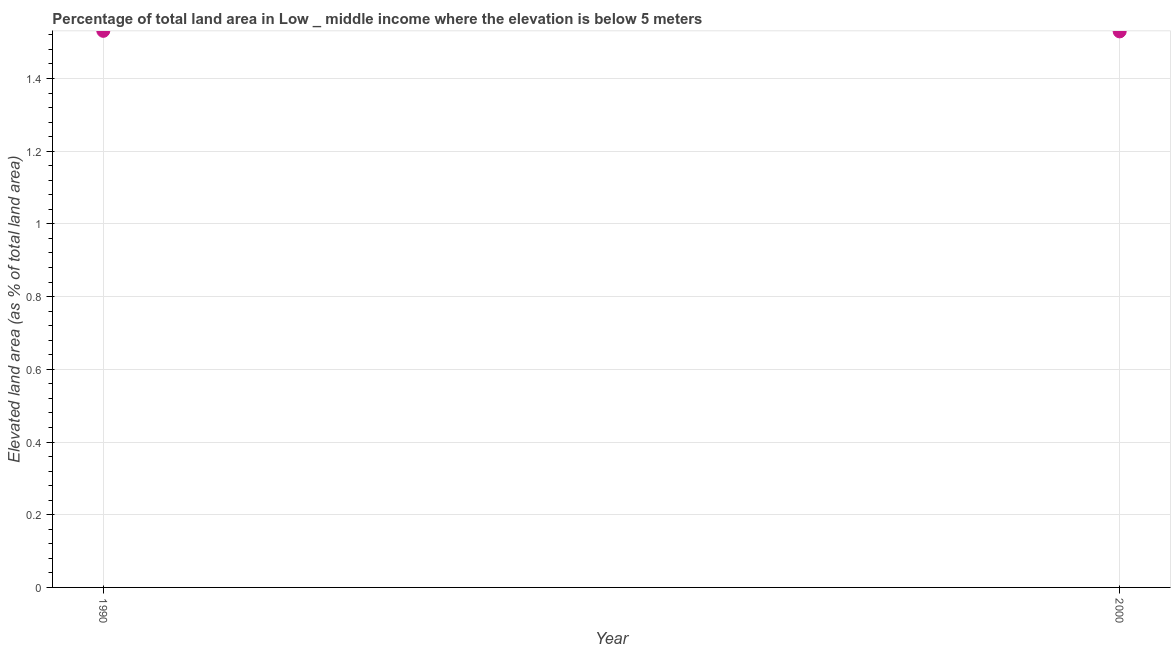What is the total elevated land area in 2000?
Your answer should be very brief. 1.53. Across all years, what is the maximum total elevated land area?
Offer a very short reply. 1.53. Across all years, what is the minimum total elevated land area?
Offer a terse response. 1.53. In which year was the total elevated land area maximum?
Your answer should be very brief. 1990. What is the sum of the total elevated land area?
Provide a succinct answer. 3.06. What is the difference between the total elevated land area in 1990 and 2000?
Offer a very short reply. 0. What is the average total elevated land area per year?
Ensure brevity in your answer.  1.53. What is the median total elevated land area?
Keep it short and to the point. 1.53. In how many years, is the total elevated land area greater than 1.4400000000000002 %?
Provide a succinct answer. 2. Do a majority of the years between 2000 and 1990 (inclusive) have total elevated land area greater than 0.6400000000000001 %?
Offer a very short reply. No. What is the ratio of the total elevated land area in 1990 to that in 2000?
Ensure brevity in your answer.  1. Is the total elevated land area in 1990 less than that in 2000?
Provide a short and direct response. No. Does the total elevated land area monotonically increase over the years?
Make the answer very short. No. How many dotlines are there?
Your answer should be compact. 1. What is the difference between two consecutive major ticks on the Y-axis?
Make the answer very short. 0.2. Are the values on the major ticks of Y-axis written in scientific E-notation?
Your response must be concise. No. Does the graph contain any zero values?
Provide a short and direct response. No. What is the title of the graph?
Provide a succinct answer. Percentage of total land area in Low _ middle income where the elevation is below 5 meters. What is the label or title of the Y-axis?
Make the answer very short. Elevated land area (as % of total land area). What is the Elevated land area (as % of total land area) in 1990?
Provide a succinct answer. 1.53. What is the Elevated land area (as % of total land area) in 2000?
Provide a short and direct response. 1.53. What is the difference between the Elevated land area (as % of total land area) in 1990 and 2000?
Provide a succinct answer. 0. What is the ratio of the Elevated land area (as % of total land area) in 1990 to that in 2000?
Ensure brevity in your answer.  1. 